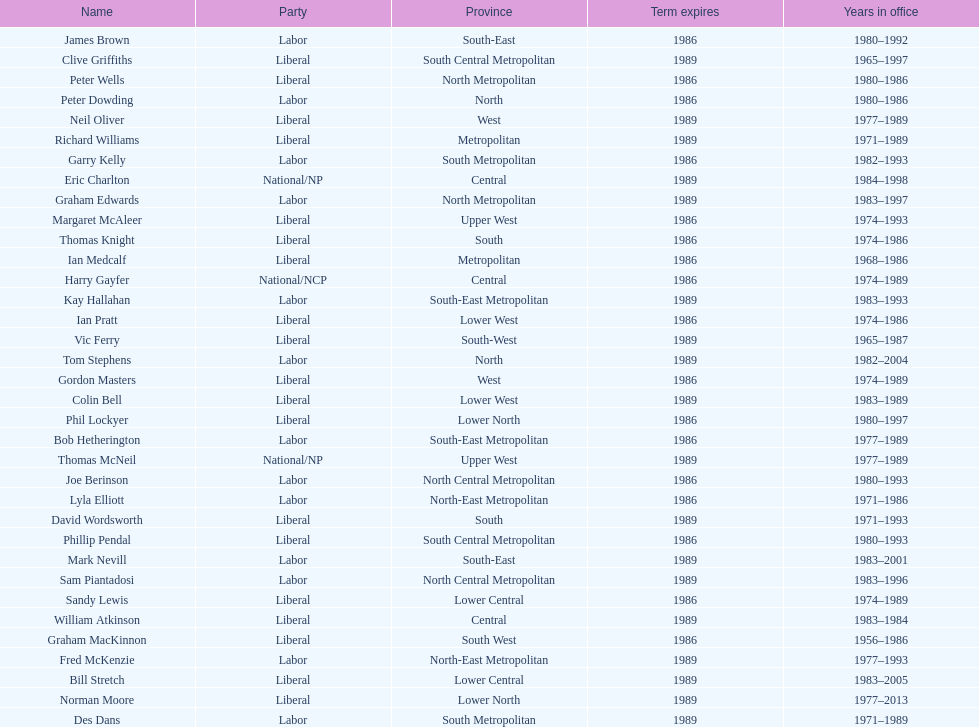What is the number of people in the liberal party? 19. 